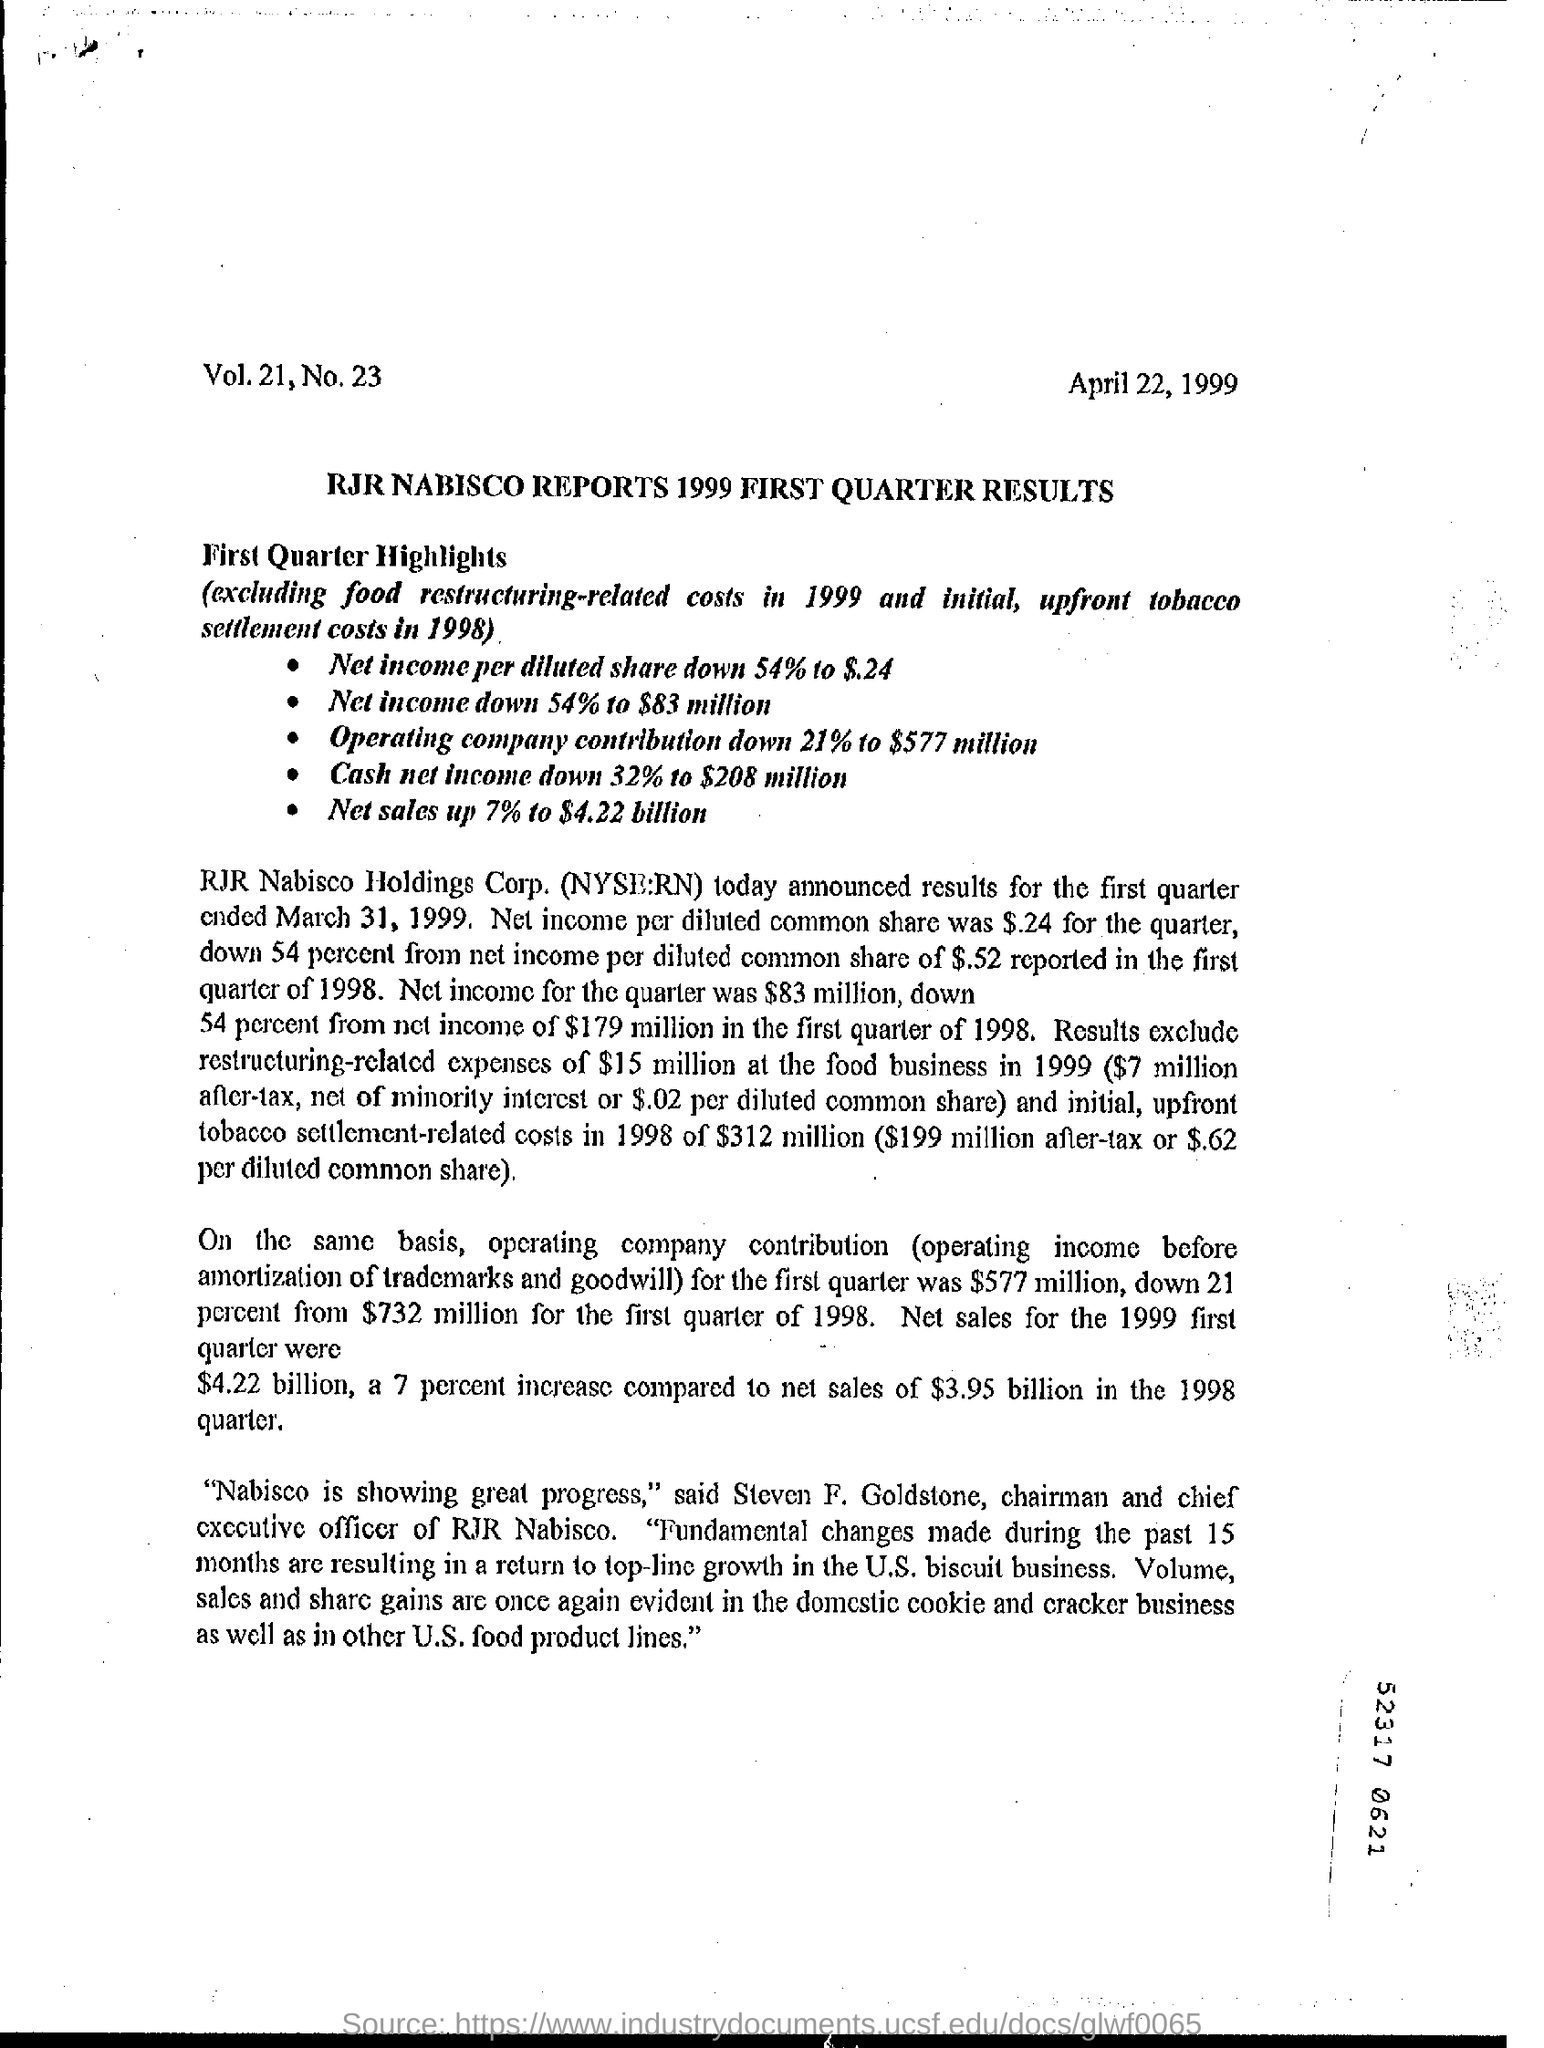Who is Steven F. Goldstone?
Provide a succinct answer. Chairman and chief executive officer of rjr nabisco. What is the net sales for the 1999 first quarter?
Provide a short and direct response. $4.22 billion. What is the date mentioned in this document?
Provide a succinct answer. April 22, 1999. 